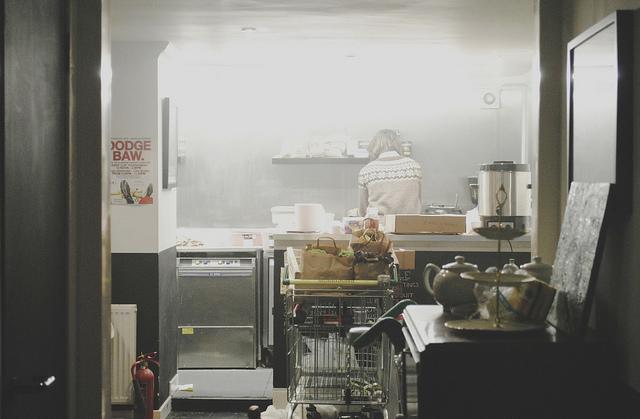Is this a house or a restaurant?
Quick response, please. Restaurant. Where is the teapot?
Short answer required. On table. What is written on the wall?
Keep it brief. Dodge baw. 